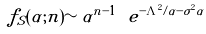Convert formula to latex. <formula><loc_0><loc_0><loc_500><loc_500>f _ { S } ( \alpha ; n ) \sim \alpha ^ { n - 1 } \ e ^ { - \Lambda ^ { 2 } / \alpha - \sigma ^ { 2 } \alpha }</formula> 